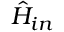Convert formula to latex. <formula><loc_0><loc_0><loc_500><loc_500>\hat { H } _ { i n }</formula> 